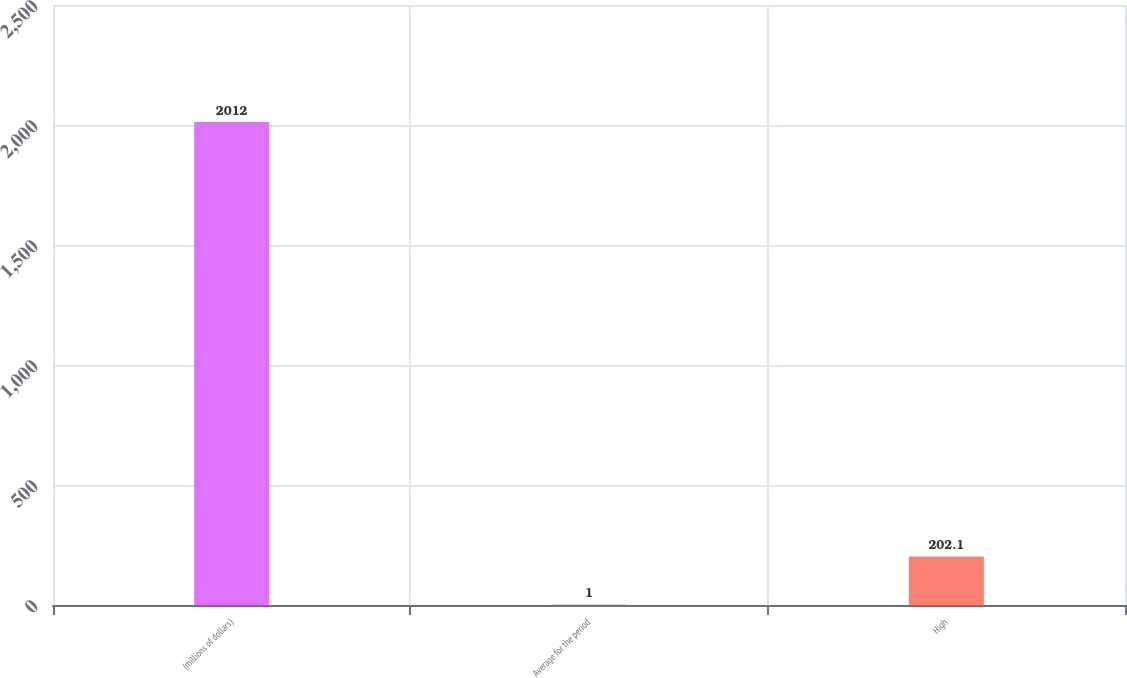Convert chart. <chart><loc_0><loc_0><loc_500><loc_500><bar_chart><fcel>(millions of dollars)<fcel>Average for the period<fcel>High<nl><fcel>2012<fcel>1<fcel>202.1<nl></chart> 